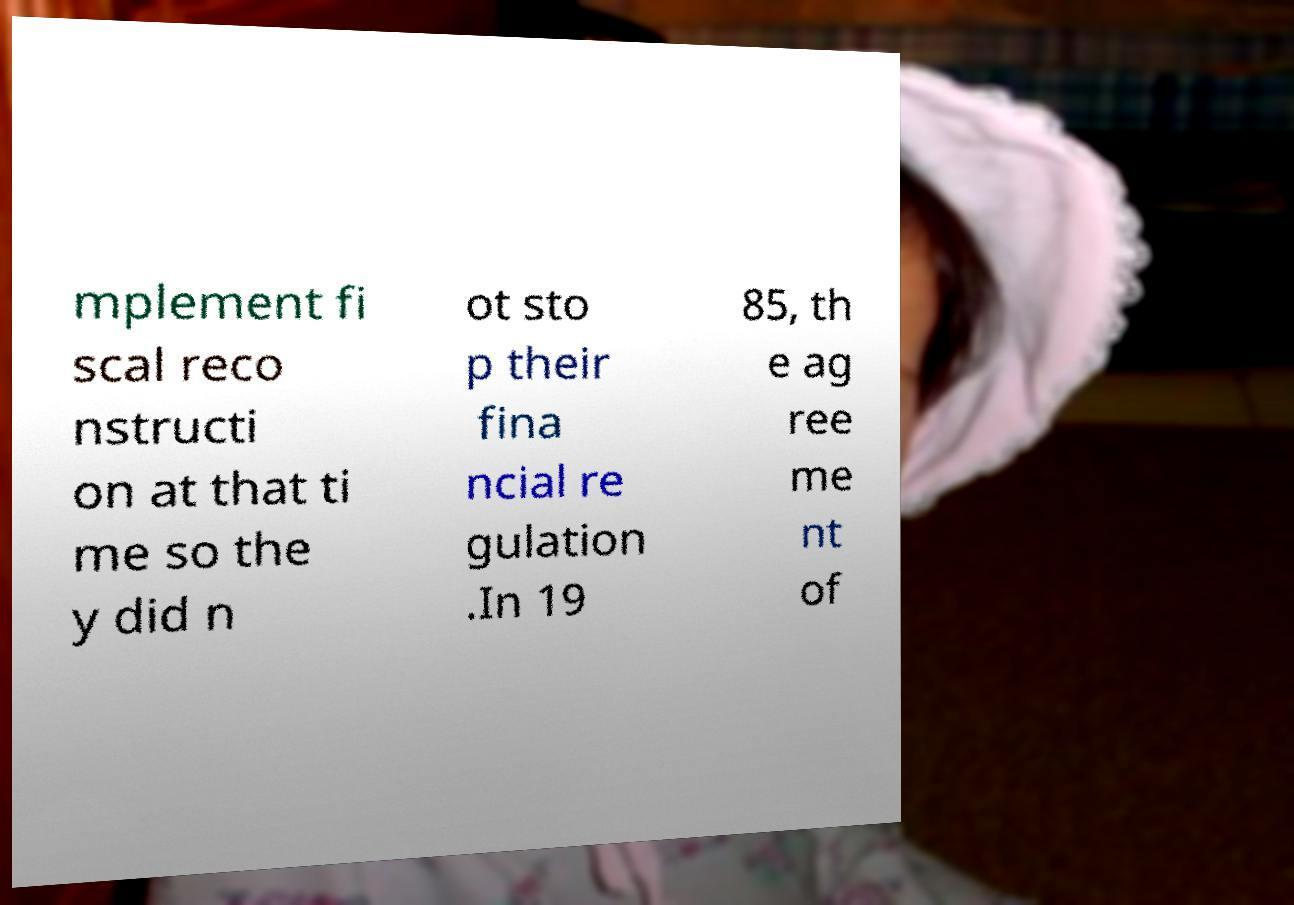Can you accurately transcribe the text from the provided image for me? mplement fi scal reco nstructi on at that ti me so the y did n ot sto p their fina ncial re gulation .In 19 85, th e ag ree me nt of 